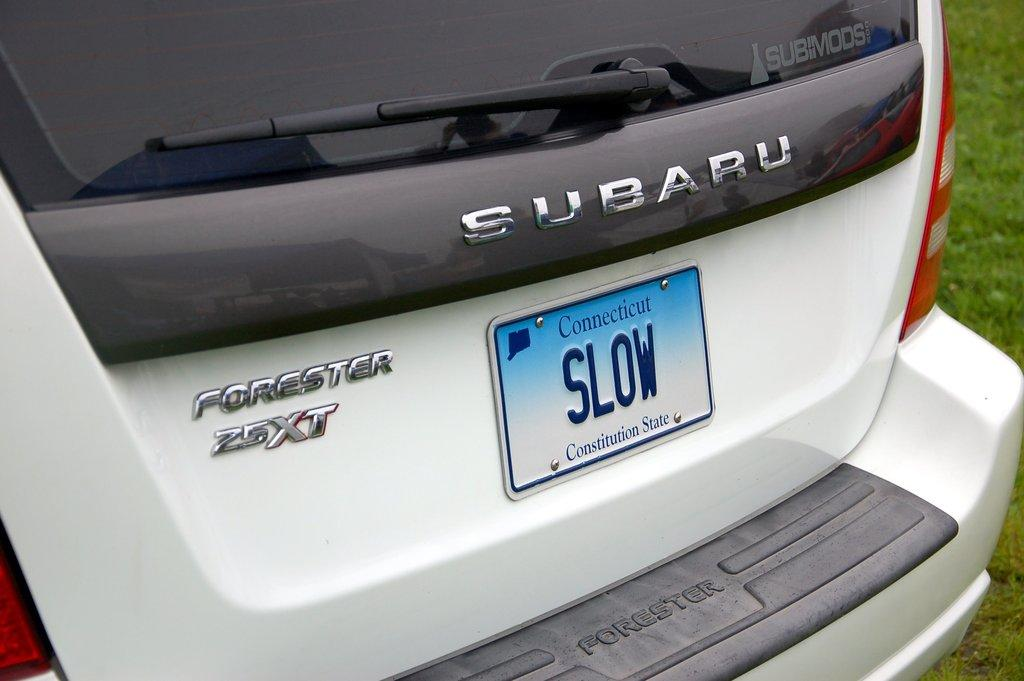<image>
Render a clear and concise summary of the photo. A Subaru with a Connecticut license plate that reads slow. 